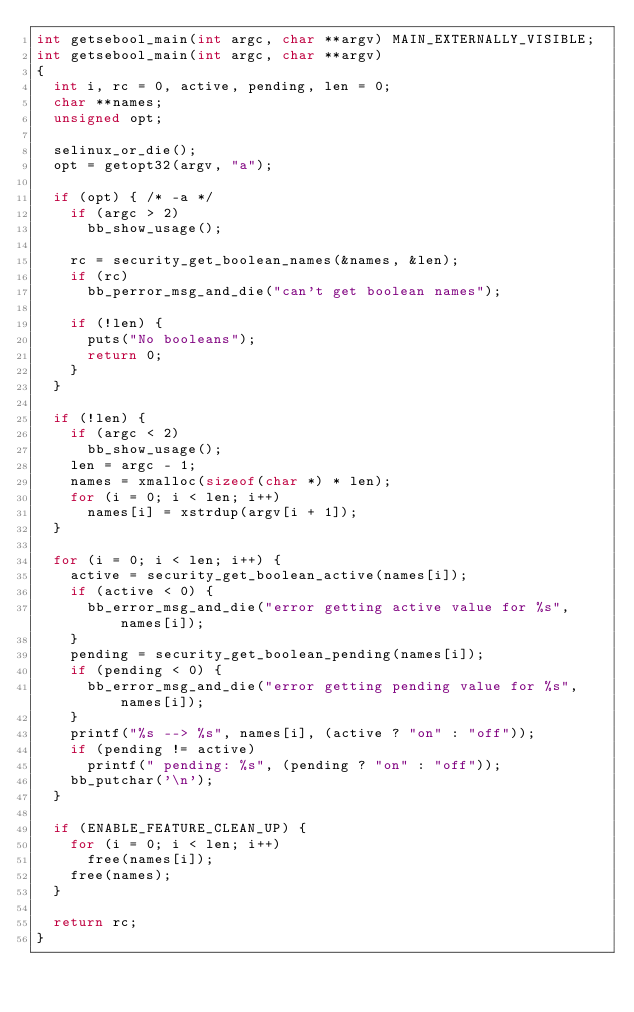<code> <loc_0><loc_0><loc_500><loc_500><_C_>int getsebool_main(int argc, char **argv) MAIN_EXTERNALLY_VISIBLE;
int getsebool_main(int argc, char **argv)
{
	int i, rc = 0, active, pending, len = 0;
	char **names;
	unsigned opt;

	selinux_or_die();
	opt = getopt32(argv, "a");

	if (opt) { /* -a */
		if (argc > 2)
			bb_show_usage();

		rc = security_get_boolean_names(&names, &len);
		if (rc)
			bb_perror_msg_and_die("can't get boolean names");

		if (!len) {
			puts("No booleans");
			return 0;
		}
	}

	if (!len) {
		if (argc < 2)
			bb_show_usage();
		len = argc - 1;
		names = xmalloc(sizeof(char *) * len);
		for (i = 0; i < len; i++)
			names[i] = xstrdup(argv[i + 1]);
	}

	for (i = 0; i < len; i++) {
		active = security_get_boolean_active(names[i]);
		if (active < 0) {
			bb_error_msg_and_die("error getting active value for %s", names[i]);
		}
		pending = security_get_boolean_pending(names[i]);
		if (pending < 0) {
			bb_error_msg_and_die("error getting pending value for %s", names[i]);
		}
		printf("%s --> %s", names[i], (active ? "on" : "off"));
		if (pending != active)
			printf(" pending: %s", (pending ? "on" : "off"));
		bb_putchar('\n');
	}

	if (ENABLE_FEATURE_CLEAN_UP) {
		for (i = 0; i < len; i++)
			free(names[i]);
		free(names);
	}

	return rc;
}
</code> 